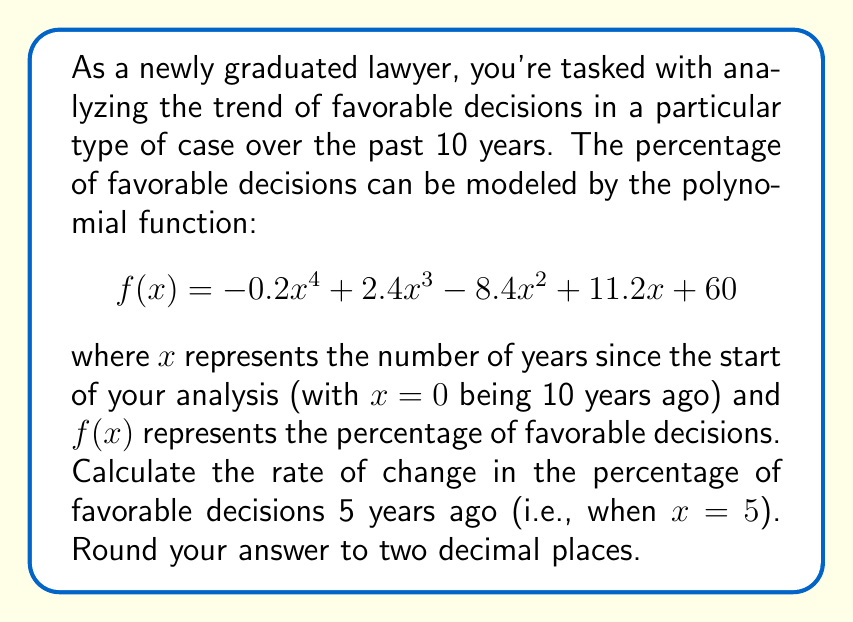Can you solve this math problem? To solve this problem, we need to follow these steps:

1) The rate of change at any point is given by the first derivative of the function. So, we need to find $f'(x)$.

2) To find $f'(x)$, we differentiate each term of $f(x)$:
   
   $$f'(x) = -0.2 \cdot 4x^3 + 2.4 \cdot 3x^2 - 8.4 \cdot 2x + 11.2$$
   
   $$f'(x) = -0.8x^3 + 7.2x^2 - 16.8x + 11.2$$

3) We want to find the rate of change 5 years ago, which means we need to calculate $f'(5)$:

   $$f'(5) = -0.8(5^3) + 7.2(5^2) - 16.8(5) + 11.2$$
   
   $$= -0.8(125) + 7.2(25) - 16.8(5) + 11.2$$
   
   $$= -100 + 180 - 84 + 11.2$$
   
   $$= 7.2$$

4) Rounding to two decimal places, we get 7.20.

This means that 5 years ago, the percentage of favorable decisions was increasing at a rate of 7.20% per year.
Answer: 7.20% per year 